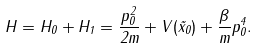<formula> <loc_0><loc_0><loc_500><loc_500>H = H _ { 0 } + H _ { 1 } = \frac { p _ { 0 } ^ { 2 } } { 2 m } + V ( \vec { x } _ { 0 } ) + \frac { \beta } { m } p _ { 0 } ^ { 4 } .</formula> 